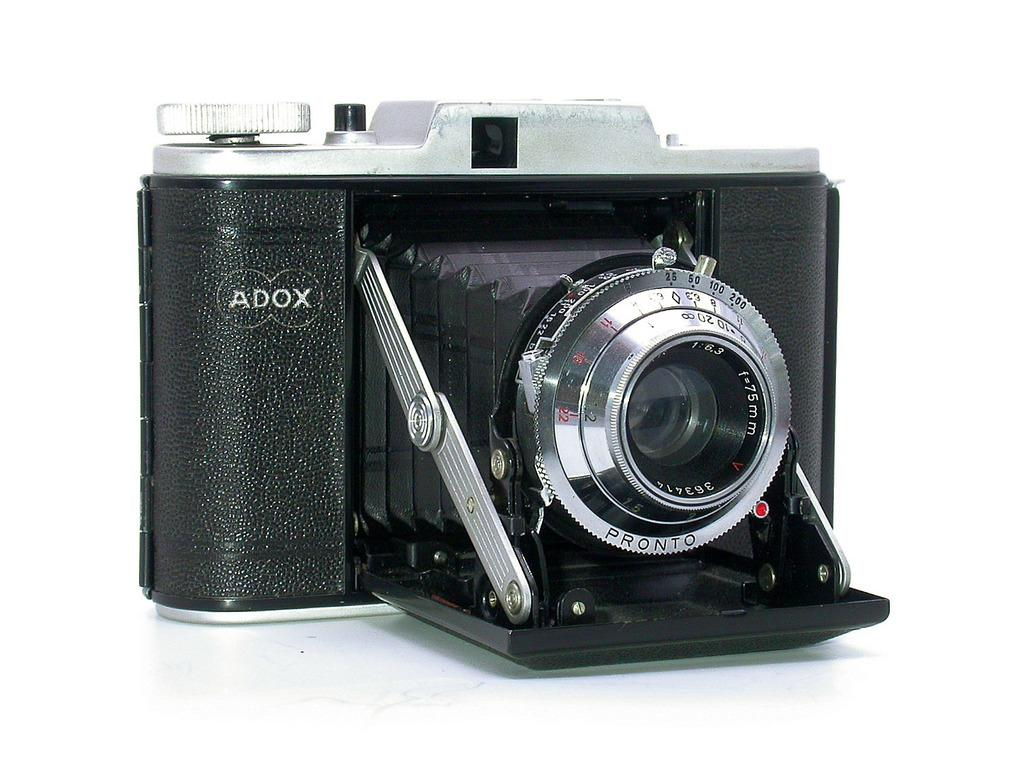What is the main object in the image? There is a camera in the image. What type of underwear is being used to take the picture with the camera in the image? There is no underwear present in the image, and the camera does not require underwear to function. 